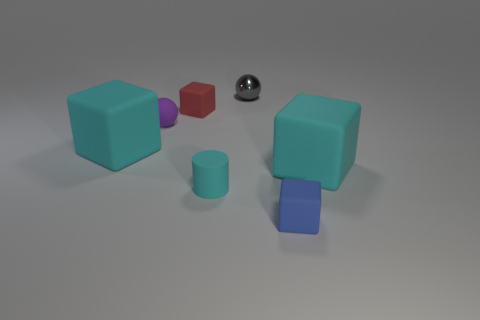Is there anything else that has the same shape as the small cyan matte thing?
Your answer should be compact. No. There is a rubber block that is the same size as the blue matte object; what color is it?
Give a very brief answer. Red. Do the tiny cylinder and the large object on the right side of the tiny cyan rubber cylinder have the same color?
Make the answer very short. Yes. How many things are either tiny blue rubber objects or red objects?
Make the answer very short. 2. Is there anything else that is the same color as the small metallic object?
Make the answer very short. No. Do the gray sphere and the large block that is on the left side of the cyan cylinder have the same material?
Make the answer very short. No. There is a large cyan matte thing on the right side of the blue matte block that is on the right side of the small red block; what is its shape?
Ensure brevity in your answer.  Cube. There is a small thing that is in front of the small purple ball and left of the gray metal sphere; what shape is it?
Keep it short and to the point. Cylinder. How many objects are either tiny objects or large matte cubes to the right of the red matte thing?
Ensure brevity in your answer.  6. There is a small purple thing that is the same shape as the small gray object; what material is it?
Offer a very short reply. Rubber. 